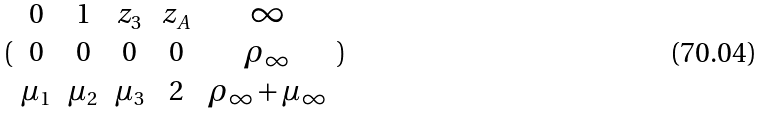<formula> <loc_0><loc_0><loc_500><loc_500>( \begin{array} { c c c c c } 0 & 1 & z _ { 3 } & z _ { A } & \infty \\ 0 & 0 & 0 & 0 & \rho _ { \infty } \\ \mu _ { 1 } & \mu _ { 2 } & \mu _ { 3 } & 2 & \rho _ { \infty } + \mu _ { \infty } \end{array} )</formula> 